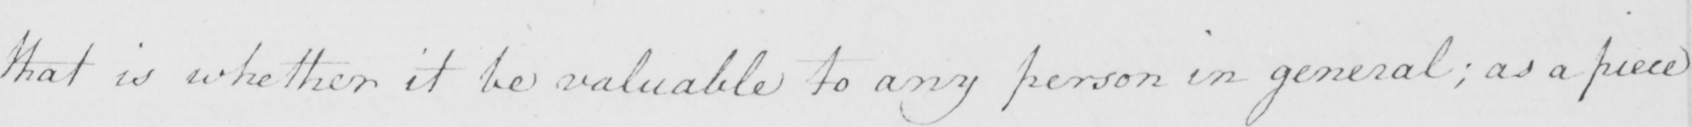Can you tell me what this handwritten text says? that is whether it be valuable to any person in general ; as a piece 